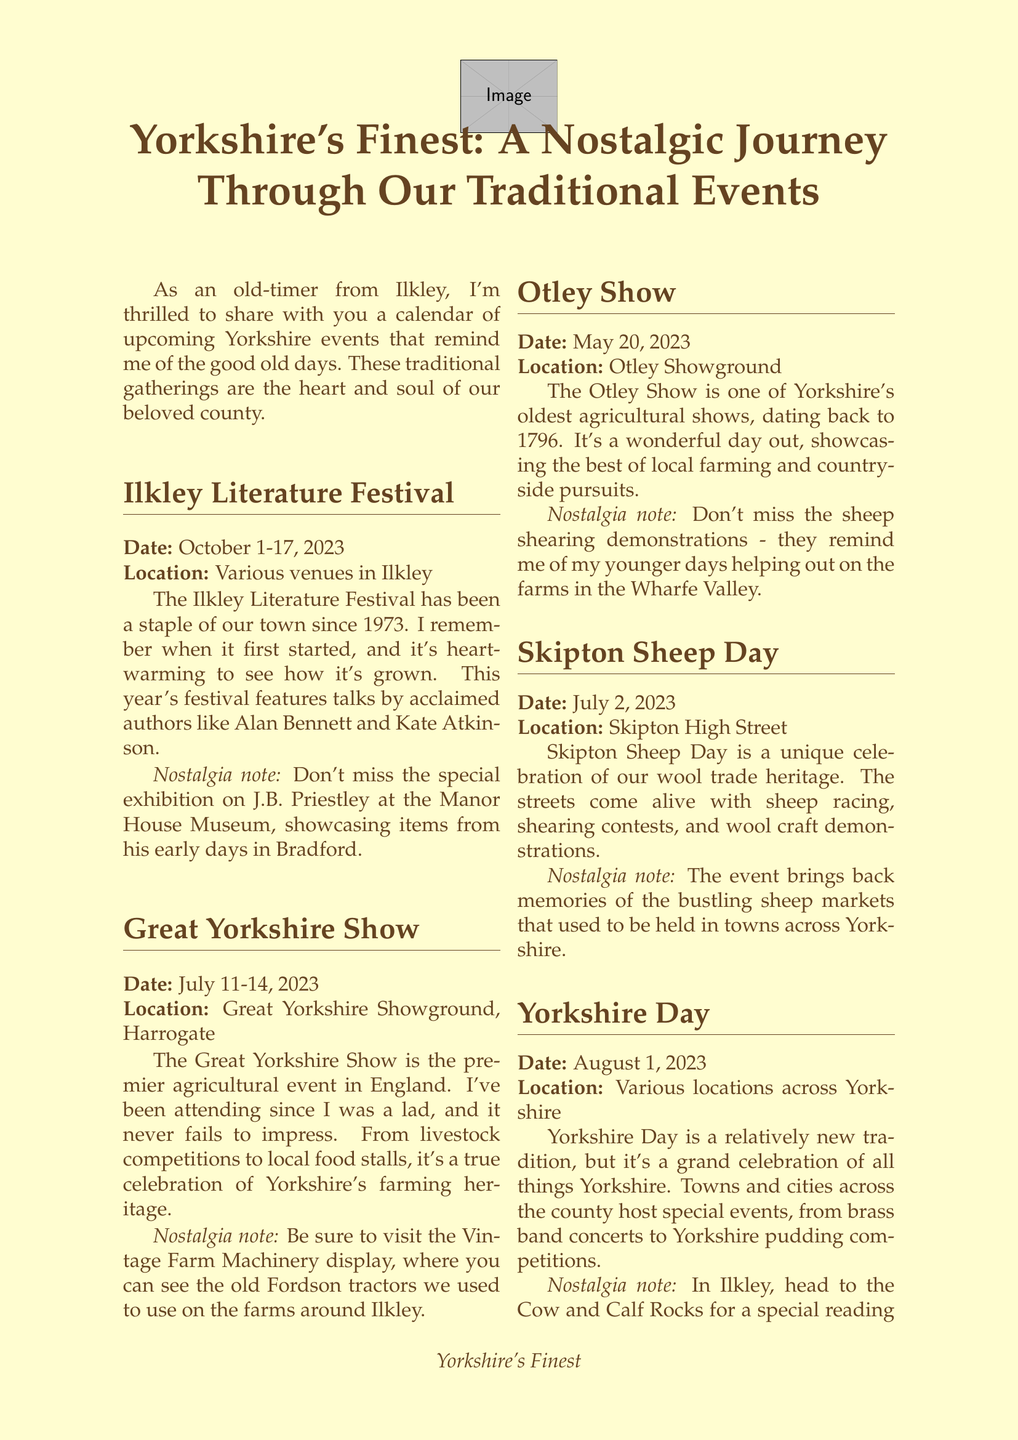What are the dates of the Ilkley Literature Festival? The document specifies that the Ilkley Literature Festival takes place from October 1 to October 17, 2023.
Answer: October 1-17, 2023 Where is the Great Yorkshire Show held? The location for the Great Yorkshire Show is mentioned as the Great Yorkshire Showground, Harrogate.
Answer: Great Yorkshire Showground, Harrogate Which author is featured at the Ilkley Literature Festival? The document highlights that acclaimed authors such as Alan Bennett and Kate Atkinson will participate in the festival.
Answer: Alan Bennett and Kate Atkinson What year did the Otley Show first take place? The document notes that the Otley Show dates back to 1796, indicating its long-standing tradition.
Answer: 1796 What is celebrated on Yorkshire Day? The document describes Yorkshire Day as a celebration of all things Yorkshire, including various local events.
Answer: All things Yorkshire Which event includes sheep racing? The document states that Skipton Sheep Day features sheep racing along with other activities.
Answer: Skipton Sheep Day What is the nostalgia note for the Great Yorkshire Show? The nostalgia note mentions visiting the Vintage Farm Machinery display to see old Fordson tractors.
Answer: Vintage Farm Machinery display How many events are listed in the newsletter? The document lists a total of five events throughout the newsletter.
Answer: Five events 